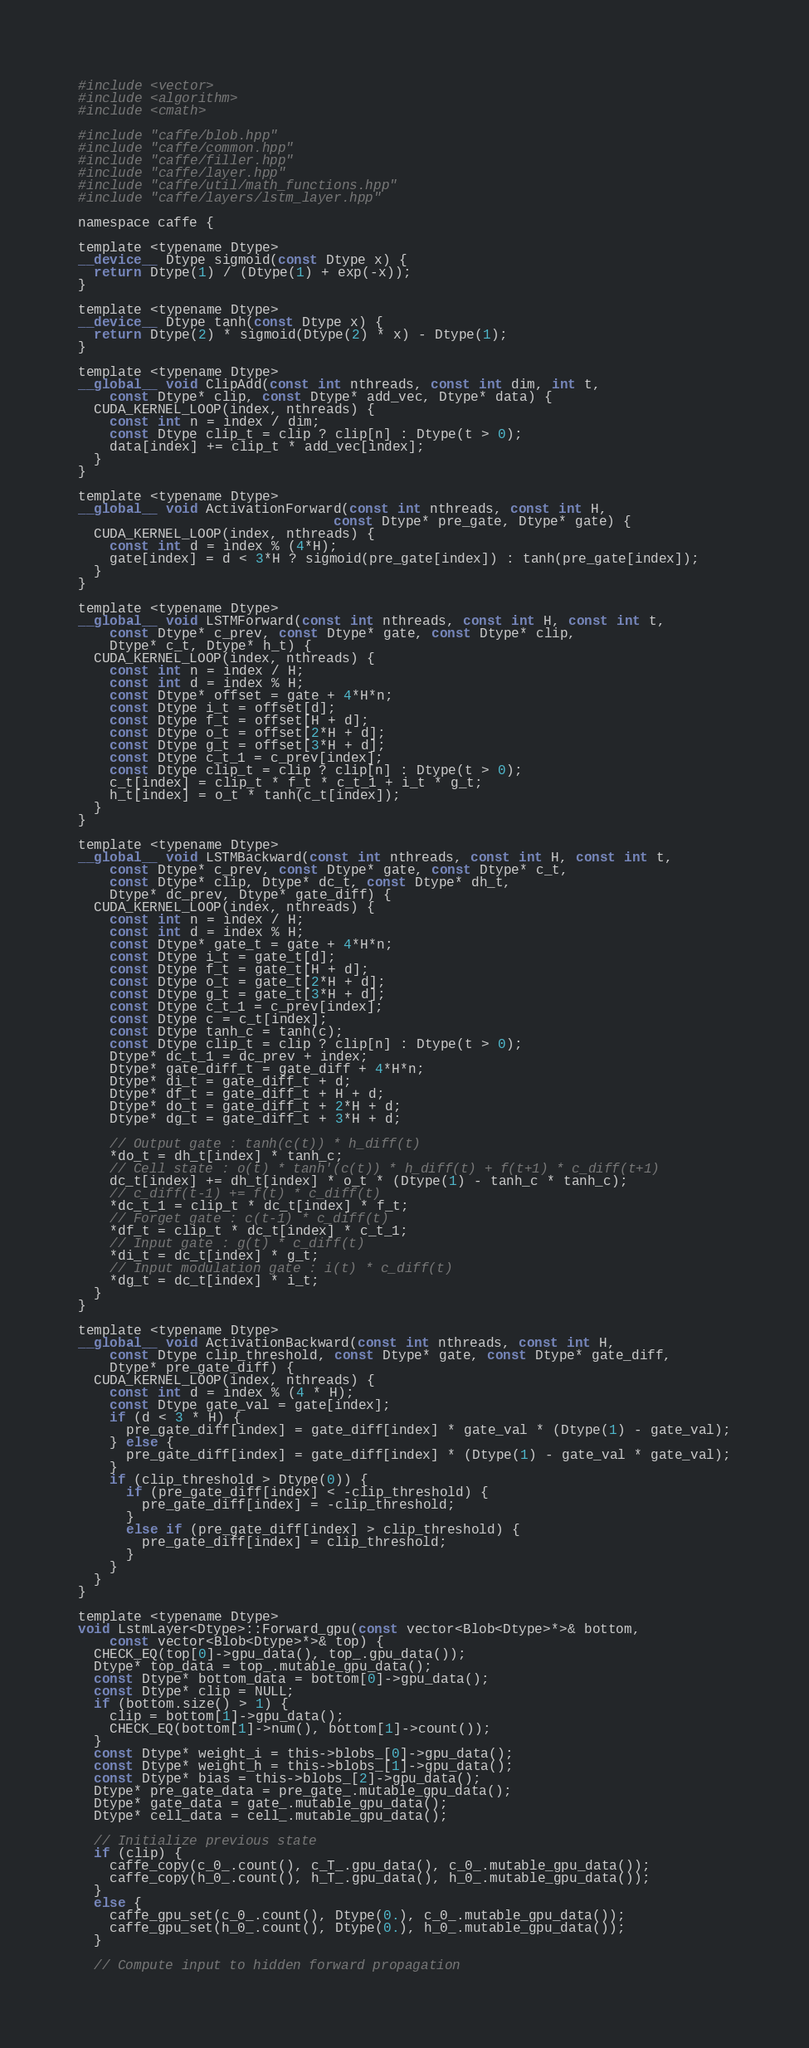<code> <loc_0><loc_0><loc_500><loc_500><_Cuda_>#include <vector>
#include <algorithm>
#include <cmath>

#include "caffe/blob.hpp"
#include "caffe/common.hpp"
#include "caffe/filler.hpp"
#include "caffe/layer.hpp"
#include "caffe/util/math_functions.hpp"
#include "caffe/layers/lstm_layer.hpp"

namespace caffe {

template <typename Dtype>
__device__ Dtype sigmoid(const Dtype x) {
  return Dtype(1) / (Dtype(1) + exp(-x));
}

template <typename Dtype>
__device__ Dtype tanh(const Dtype x) {
  return Dtype(2) * sigmoid(Dtype(2) * x) - Dtype(1);
}

template <typename Dtype>
__global__ void ClipAdd(const int nthreads, const int dim, int t,
    const Dtype* clip, const Dtype* add_vec, Dtype* data) {
  CUDA_KERNEL_LOOP(index, nthreads) {
    const int n = index / dim;
    const Dtype clip_t = clip ? clip[n] : Dtype(t > 0);
    data[index] += clip_t * add_vec[index];
  }
}

template <typename Dtype>
__global__ void ActivationForward(const int nthreads, const int H,
                                const Dtype* pre_gate, Dtype* gate) {
  CUDA_KERNEL_LOOP(index, nthreads) {
    const int d = index % (4*H);
    gate[index] = d < 3*H ? sigmoid(pre_gate[index]) : tanh(pre_gate[index]);
  }
}

template <typename Dtype>
__global__ void LSTMForward(const int nthreads, const int H, const int t,
    const Dtype* c_prev, const Dtype* gate, const Dtype* clip,
    Dtype* c_t, Dtype* h_t) {
  CUDA_KERNEL_LOOP(index, nthreads) {
    const int n = index / H;
    const int d = index % H;
    const Dtype* offset = gate + 4*H*n;
    const Dtype i_t = offset[d];
    const Dtype f_t = offset[H + d];
    const Dtype o_t = offset[2*H + d];
    const Dtype g_t = offset[3*H + d];
    const Dtype c_t_1 = c_prev[index];
    const Dtype clip_t = clip ? clip[n] : Dtype(t > 0);
    c_t[index] = clip_t * f_t * c_t_1 + i_t * g_t;
    h_t[index] = o_t * tanh(c_t[index]);
  }
}

template <typename Dtype>
__global__ void LSTMBackward(const int nthreads, const int H, const int t, 
    const Dtype* c_prev, const Dtype* gate, const Dtype* c_t, 
    const Dtype* clip, Dtype* dc_t, const Dtype* dh_t, 
    Dtype* dc_prev, Dtype* gate_diff) {
  CUDA_KERNEL_LOOP(index, nthreads) {
    const int n = index / H;
    const int d = index % H;
    const Dtype* gate_t = gate + 4*H*n;
    const Dtype i_t = gate_t[d];
    const Dtype f_t = gate_t[H + d];
    const Dtype o_t = gate_t[2*H + d];
    const Dtype g_t = gate_t[3*H + d];
    const Dtype c_t_1 = c_prev[index];
    const Dtype c = c_t[index];
    const Dtype tanh_c = tanh(c);
    const Dtype clip_t = clip ? clip[n] : Dtype(t > 0);
    Dtype* dc_t_1 = dc_prev + index;
    Dtype* gate_diff_t = gate_diff + 4*H*n;
    Dtype* di_t = gate_diff_t + d;
    Dtype* df_t = gate_diff_t + H + d;
    Dtype* do_t = gate_diff_t + 2*H + d;
    Dtype* dg_t = gate_diff_t + 3*H + d;
    
    // Output gate : tanh(c(t)) * h_diff(t)
    *do_t = dh_t[index] * tanh_c;
    // Cell state : o(t) * tanh'(c(t)) * h_diff(t) + f(t+1) * c_diff(t+1)
    dc_t[index] += dh_t[index] * o_t * (Dtype(1) - tanh_c * tanh_c);
    // c_diff(t-1) += f(t) * c_diff(t)
    *dc_t_1 = clip_t * dc_t[index] * f_t;
    // Forget gate : c(t-1) * c_diff(t)
    *df_t = clip_t * dc_t[index] * c_t_1;
    // Input gate : g(t) * c_diff(t)
    *di_t = dc_t[index] * g_t;
    // Input modulation gate : i(t) * c_diff(t)
    *dg_t = dc_t[index] * i_t;
  }
}

template <typename Dtype>
__global__ void ActivationBackward(const int nthreads, const int H, 
    const Dtype clip_threshold, const Dtype* gate, const Dtype* gate_diff, 
    Dtype* pre_gate_diff) {
  CUDA_KERNEL_LOOP(index, nthreads) {
    const int d = index % (4 * H);
    const Dtype gate_val = gate[index];
    if (d < 3 * H) {
      pre_gate_diff[index] = gate_diff[index] * gate_val * (Dtype(1) - gate_val);
    } else {
      pre_gate_diff[index] = gate_diff[index] * (Dtype(1) - gate_val * gate_val);
    }
    if (clip_threshold > Dtype(0)) {
      if (pre_gate_diff[index] < -clip_threshold) {
        pre_gate_diff[index] = -clip_threshold;
      }
      else if (pre_gate_diff[index] > clip_threshold) {
        pre_gate_diff[index] = clip_threshold;
      }
    }
  }
}

template <typename Dtype>
void LstmLayer<Dtype>::Forward_gpu(const vector<Blob<Dtype>*>& bottom,
    const vector<Blob<Dtype>*>& top) {
  CHECK_EQ(top[0]->gpu_data(), top_.gpu_data());
  Dtype* top_data = top_.mutable_gpu_data();
  const Dtype* bottom_data = bottom[0]->gpu_data();
  const Dtype* clip = NULL;
  if (bottom.size() > 1) {
    clip = bottom[1]->gpu_data();
    CHECK_EQ(bottom[1]->num(), bottom[1]->count());
  }
  const Dtype* weight_i = this->blobs_[0]->gpu_data();
  const Dtype* weight_h = this->blobs_[1]->gpu_data();
  const Dtype* bias = this->blobs_[2]->gpu_data();
  Dtype* pre_gate_data = pre_gate_.mutable_gpu_data();
  Dtype* gate_data = gate_.mutable_gpu_data();
  Dtype* cell_data = cell_.mutable_gpu_data();

  // Initialize previous state
  if (clip) {
    caffe_copy(c_0_.count(), c_T_.gpu_data(), c_0_.mutable_gpu_data());
    caffe_copy(h_0_.count(), h_T_.gpu_data(), h_0_.mutable_gpu_data());
  }
  else {
    caffe_gpu_set(c_0_.count(), Dtype(0.), c_0_.mutable_gpu_data());
    caffe_gpu_set(h_0_.count(), Dtype(0.), h_0_.mutable_gpu_data());
  }

  // Compute input to hidden forward propagation</code> 